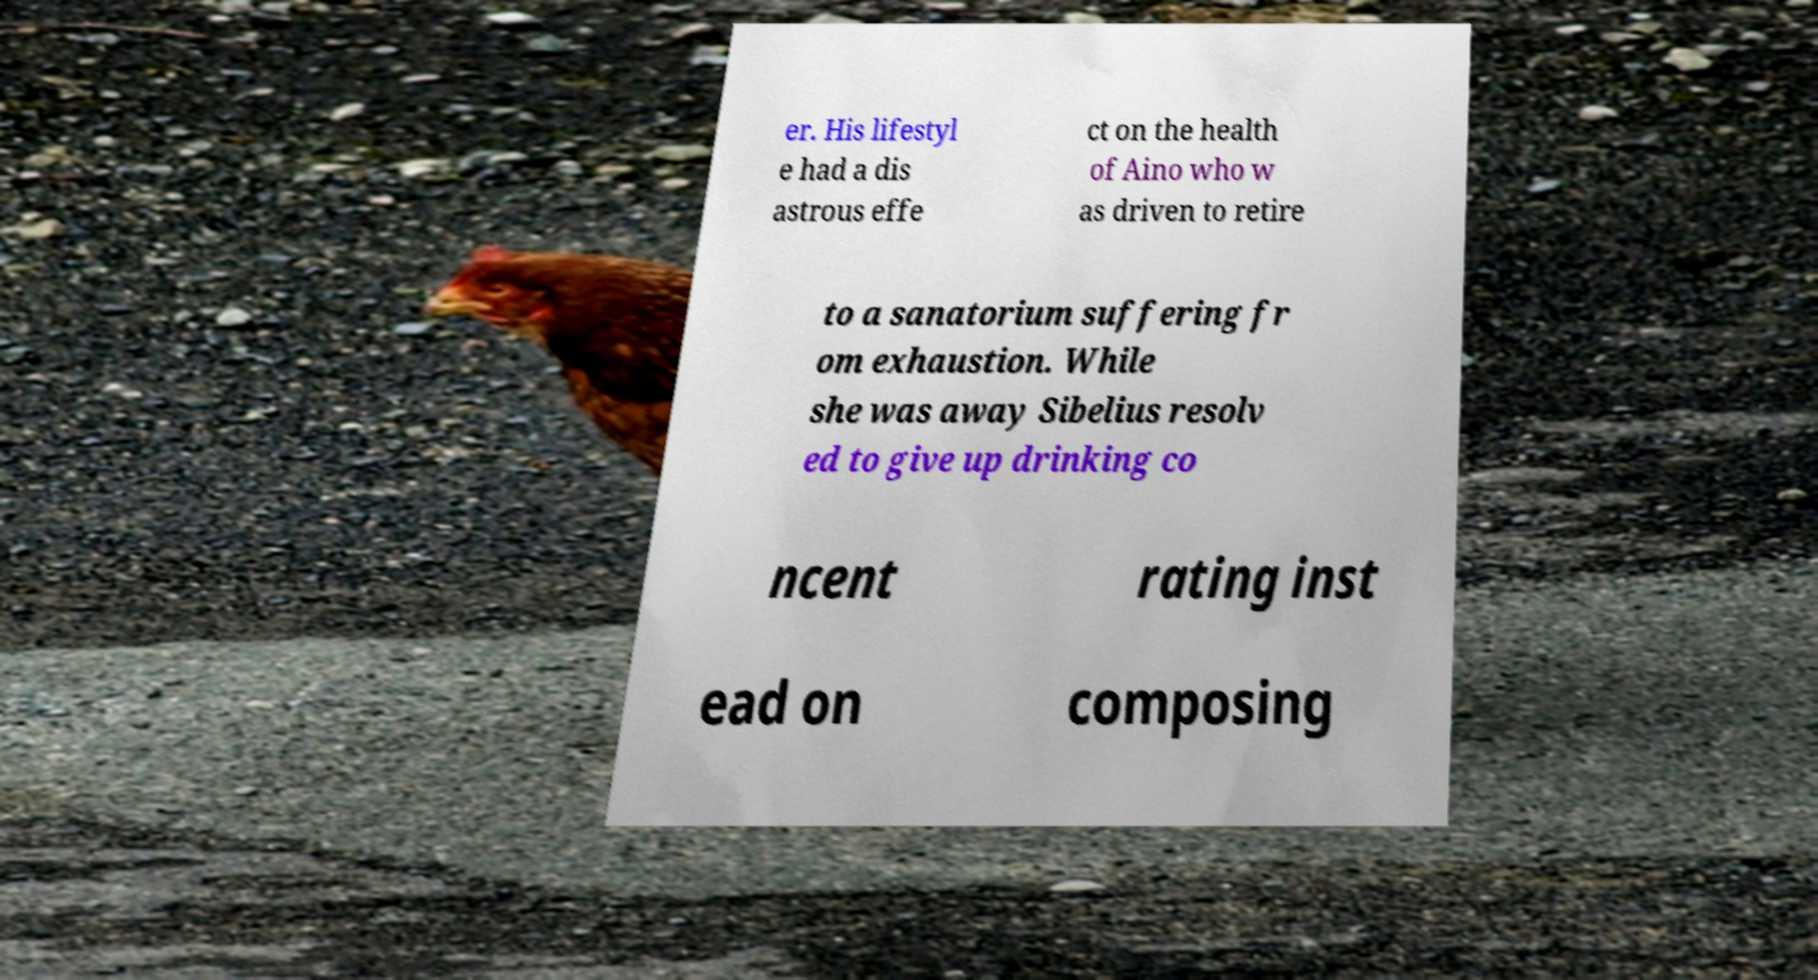I need the written content from this picture converted into text. Can you do that? er. His lifestyl e had a dis astrous effe ct on the health of Aino who w as driven to retire to a sanatorium suffering fr om exhaustion. While she was away Sibelius resolv ed to give up drinking co ncent rating inst ead on composing 